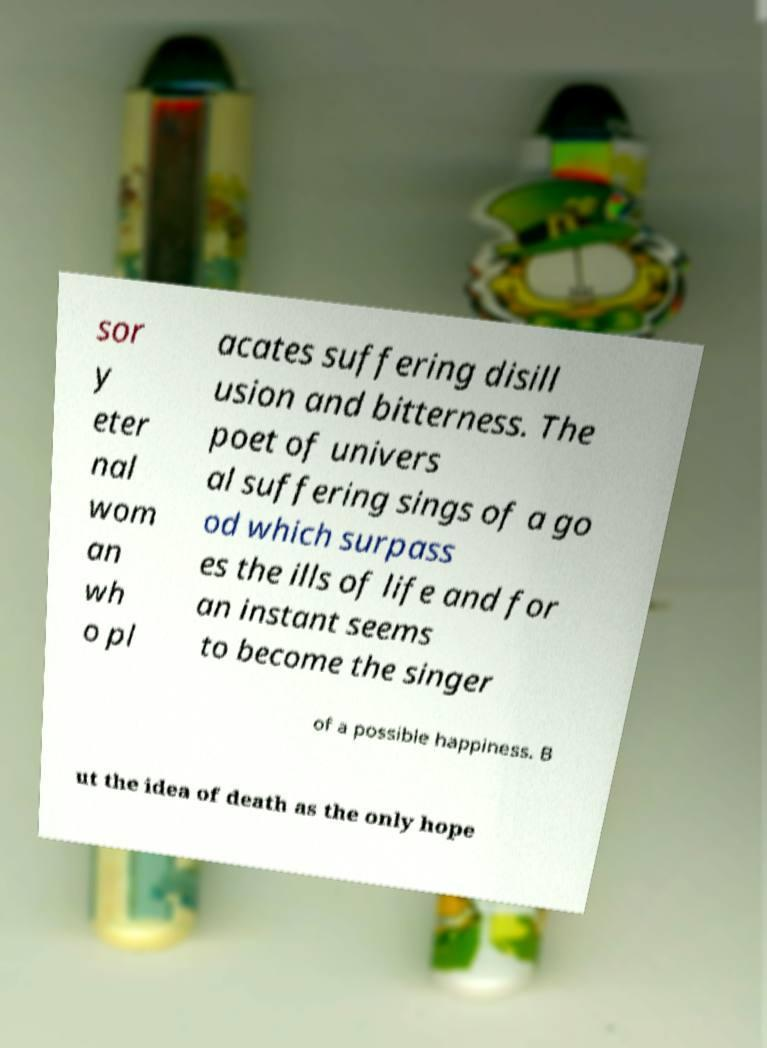Could you extract and type out the text from this image? sor y eter nal wom an wh o pl acates suffering disill usion and bitterness. The poet of univers al suffering sings of a go od which surpass es the ills of life and for an instant seems to become the singer of a possible happiness. B ut the idea of death as the only hope 